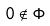Convert formula to latex. <formula><loc_0><loc_0><loc_500><loc_500>0 \notin \Phi</formula> 